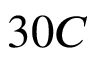Convert formula to latex. <formula><loc_0><loc_0><loc_500><loc_500>3 0 C</formula> 